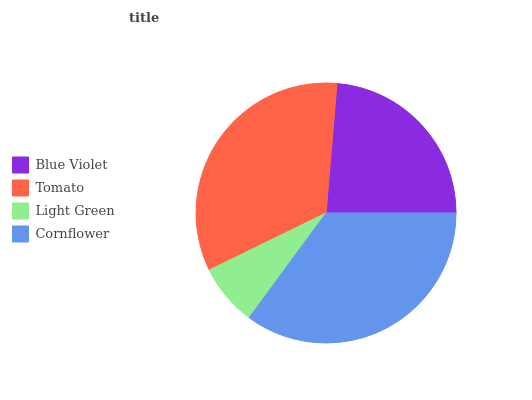Is Light Green the minimum?
Answer yes or no. Yes. Is Cornflower the maximum?
Answer yes or no. Yes. Is Tomato the minimum?
Answer yes or no. No. Is Tomato the maximum?
Answer yes or no. No. Is Tomato greater than Blue Violet?
Answer yes or no. Yes. Is Blue Violet less than Tomato?
Answer yes or no. Yes. Is Blue Violet greater than Tomato?
Answer yes or no. No. Is Tomato less than Blue Violet?
Answer yes or no. No. Is Tomato the high median?
Answer yes or no. Yes. Is Blue Violet the low median?
Answer yes or no. Yes. Is Light Green the high median?
Answer yes or no. No. Is Tomato the low median?
Answer yes or no. No. 